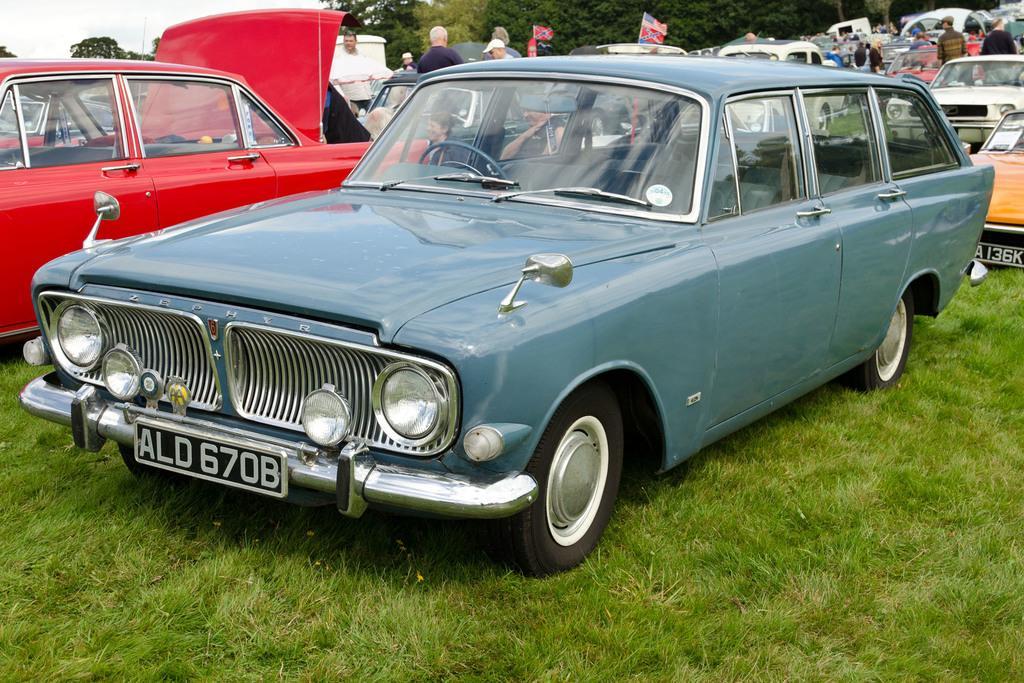Describe this image in one or two sentences. In this image in the front there is a car and there's grass on the ground. In the background there are cars, persons, flags and trees. 